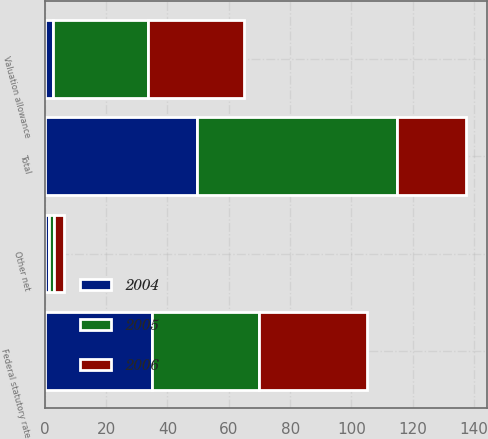Convert chart to OTSL. <chart><loc_0><loc_0><loc_500><loc_500><stacked_bar_chart><ecel><fcel>Federal statutory rate<fcel>Valuation allowance<fcel>Other net<fcel>Total<nl><fcel>2004<fcel>35<fcel>2.6<fcel>1.2<fcel>49.6<nl><fcel>2006<fcel>35<fcel>31.1<fcel>3.3<fcel>22.3<nl><fcel>2005<fcel>35<fcel>31.1<fcel>1.8<fcel>65.4<nl></chart> 